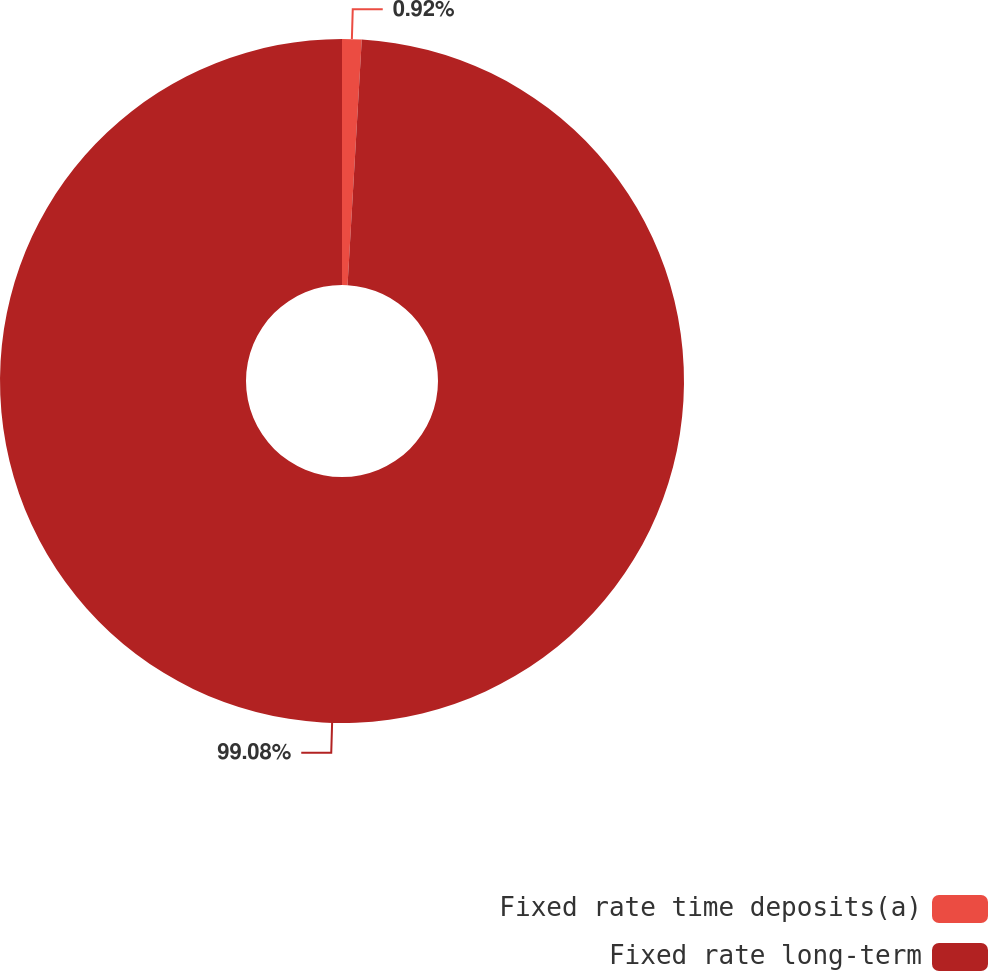Convert chart. <chart><loc_0><loc_0><loc_500><loc_500><pie_chart><fcel>Fixed rate time deposits(a)<fcel>Fixed rate long-term<nl><fcel>0.92%<fcel>99.08%<nl></chart> 